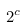<formula> <loc_0><loc_0><loc_500><loc_500>2 ^ { c }</formula> 